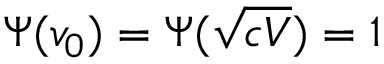Convert formula to latex. <formula><loc_0><loc_0><loc_500><loc_500>\Psi ( v _ { 0 } ) = \Psi ( \sqrt { c V } ) = 1</formula> 